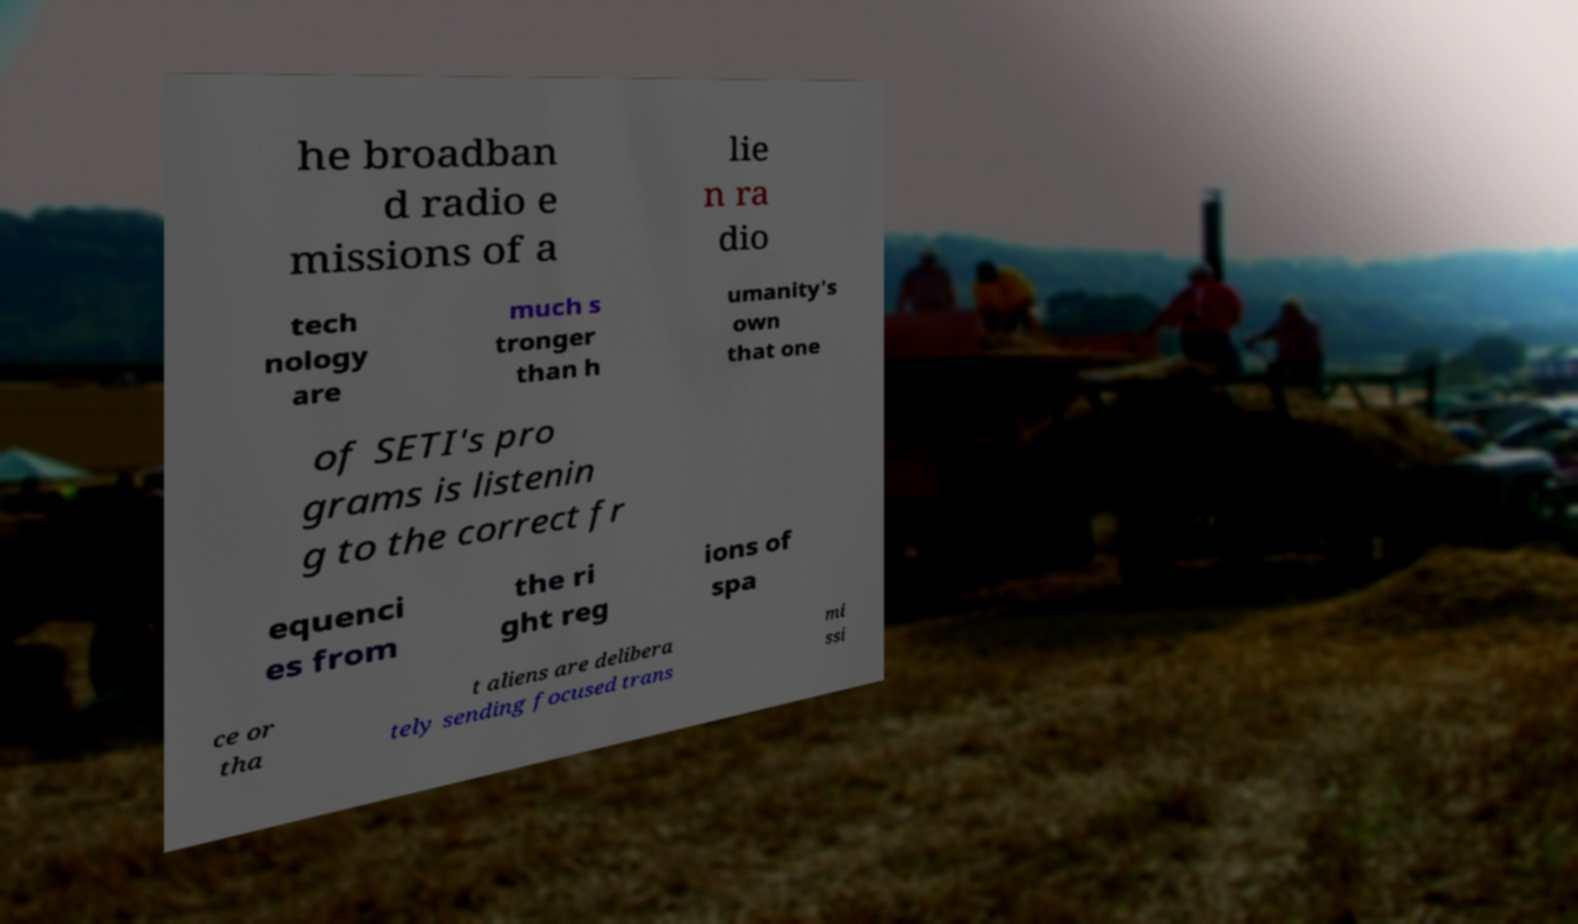I need the written content from this picture converted into text. Can you do that? he broadban d radio e missions of a lie n ra dio tech nology are much s tronger than h umanity's own that one of SETI's pro grams is listenin g to the correct fr equenci es from the ri ght reg ions of spa ce or tha t aliens are delibera tely sending focused trans mi ssi 